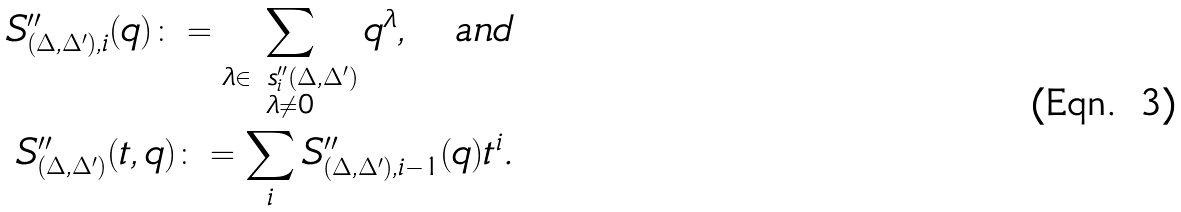<formula> <loc_0><loc_0><loc_500><loc_500>S ^ { \prime \prime } _ { ( \Delta , \Delta ^ { \prime } ) , i } ( q ) \colon = \sum _ { \substack { \lambda \in \ s ^ { \prime \prime } _ { i } ( \Delta , \Delta ^ { \prime } ) \\ \lambda \neq 0 } } q ^ { \lambda } , \quad \text {and} \\ S ^ { \prime \prime } _ { ( \Delta , \Delta ^ { \prime } ) } ( t , q ) \colon = \sum _ { i } S ^ { \prime \prime } _ { ( \Delta , \Delta ^ { \prime } ) , i - 1 } ( q ) t ^ { i } .</formula> 